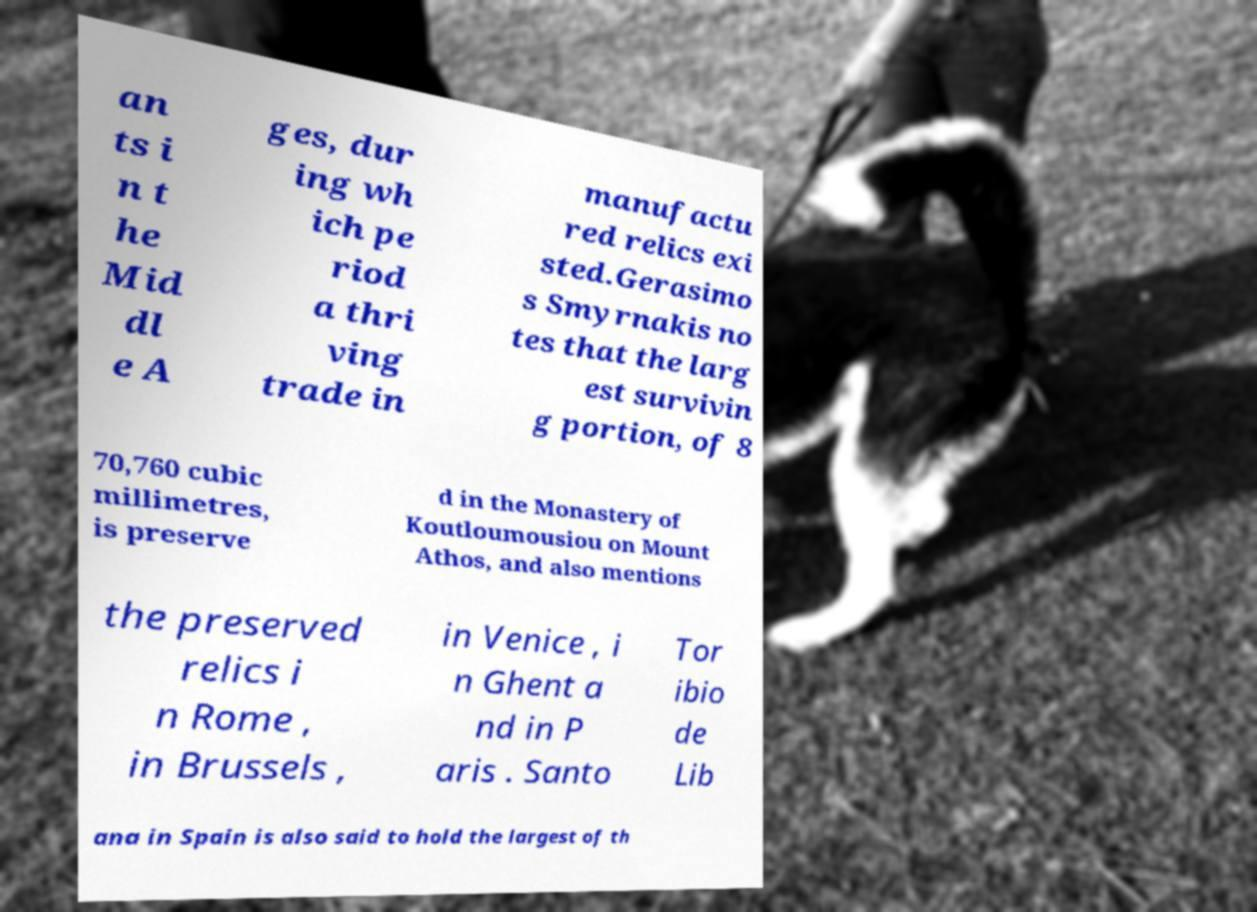Please identify and transcribe the text found in this image. an ts i n t he Mid dl e A ges, dur ing wh ich pe riod a thri ving trade in manufactu red relics exi sted.Gerasimo s Smyrnakis no tes that the larg est survivin g portion, of 8 70,760 cubic millimetres, is preserve d in the Monastery of Koutloumousiou on Mount Athos, and also mentions the preserved relics i n Rome , in Brussels , in Venice , i n Ghent a nd in P aris . Santo Tor ibio de Lib ana in Spain is also said to hold the largest of th 